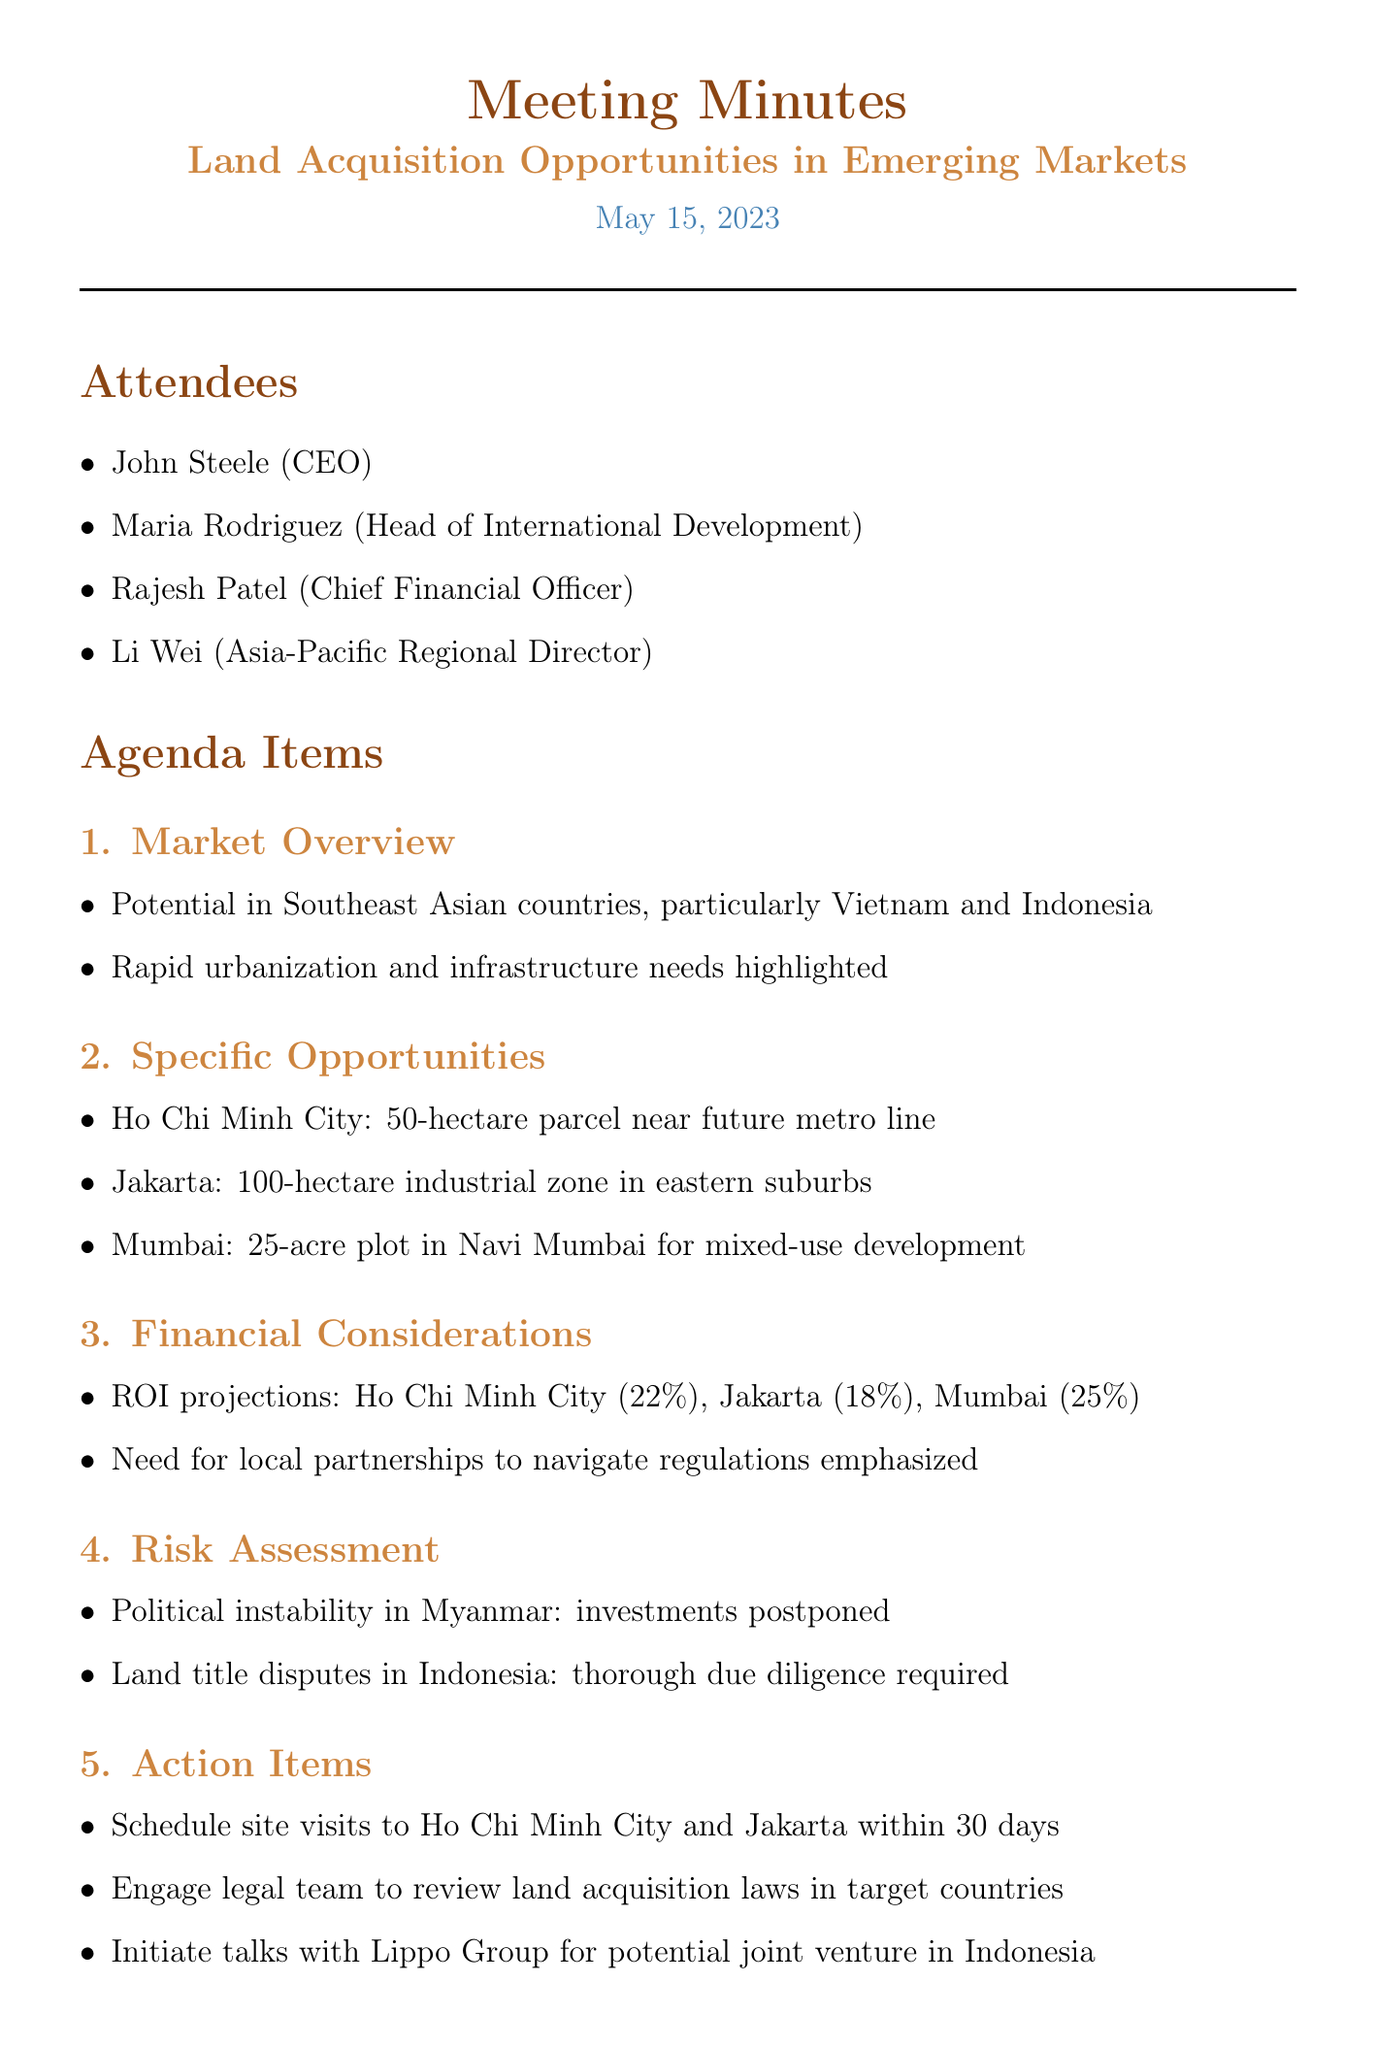What is the date of the meeting? The date of the meeting is clearly stated in the document as May 15, 2023.
Answer: May 15, 2023 Who is the Asia-Pacific Regional Director? The document lists Li Wei as the Asia-Pacific Regional Director among the attendees.
Answer: Li Wei What is the ROI projection for Ho Chi Minh City? The CFO presented a specific ROI projection for Ho Chi Minh City of 22%.
Answer: 22% What is the size of the plot in Navi Mumbai? The document mentions a 25-acre plot in Navi Mumbai for mixed-use development.
Answer: 25-acre Which country is experiencing political instability that affects investments? The document states that political instability in Myanmar led to postponement of investments.
Answer: Myanmar What is one action item decided in the meeting? The meeting details an action item to schedule site visits to Ho Chi Minh City and Jakarta within 30 days.
Answer: Schedule site visits What is a concern regarding land acquisition in Indonesia? The document highlights concerns about land title disputes in Indonesia requiring thorough due diligence.
Answer: Land title disputes When is the follow-up meeting scheduled? The document specifies that the follow-up meeting is scheduled for June 15th to review progress.
Answer: June 15th What is the potential joint venture mentioned in the document? The document mentions initiating talks with Lippo Group for a potential joint venture in Indonesia.
Answer: Lippo Group 